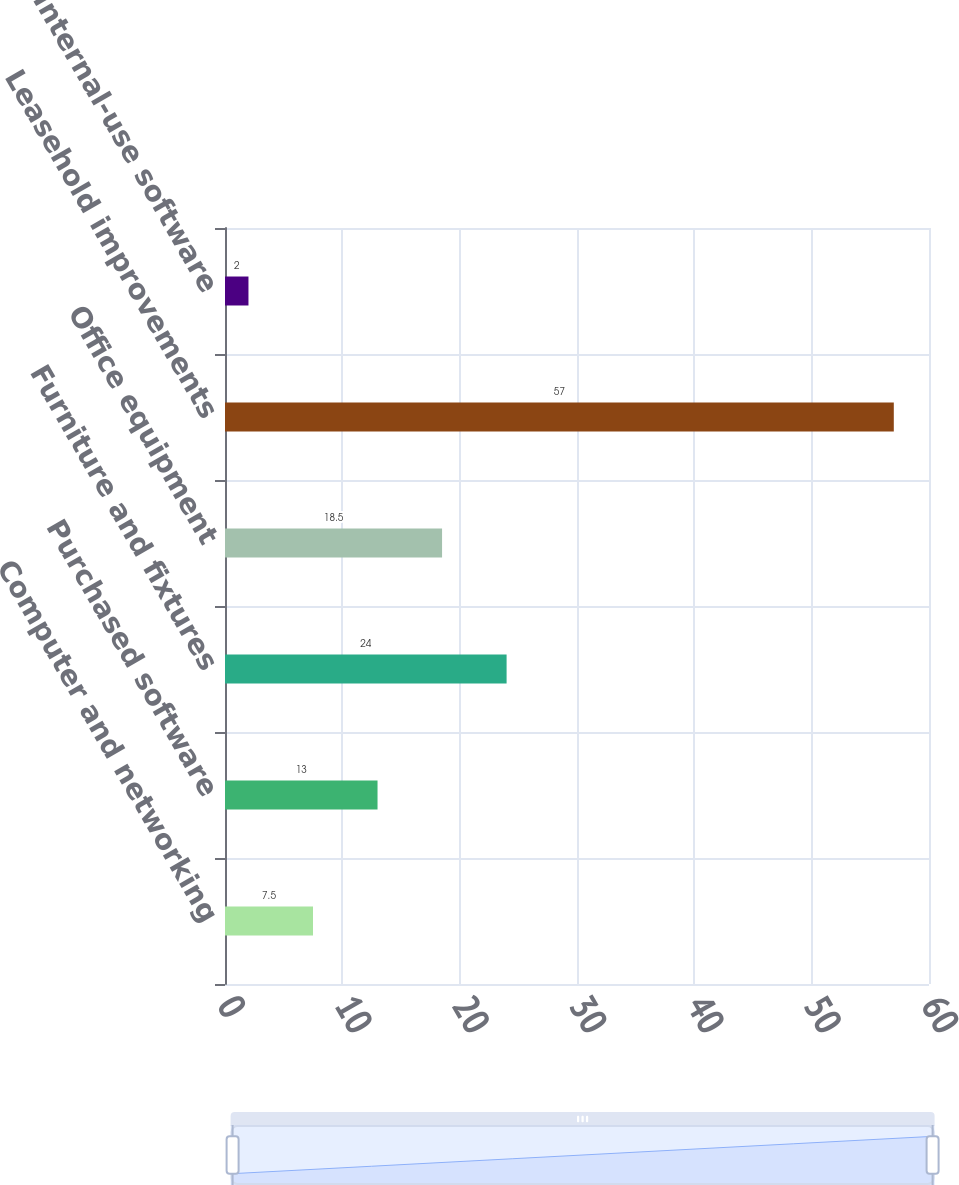Convert chart. <chart><loc_0><loc_0><loc_500><loc_500><bar_chart><fcel>Computer and networking<fcel>Purchased software<fcel>Furniture and fixtures<fcel>Office equipment<fcel>Leasehold improvements<fcel>Internal-use software<nl><fcel>7.5<fcel>13<fcel>24<fcel>18.5<fcel>57<fcel>2<nl></chart> 